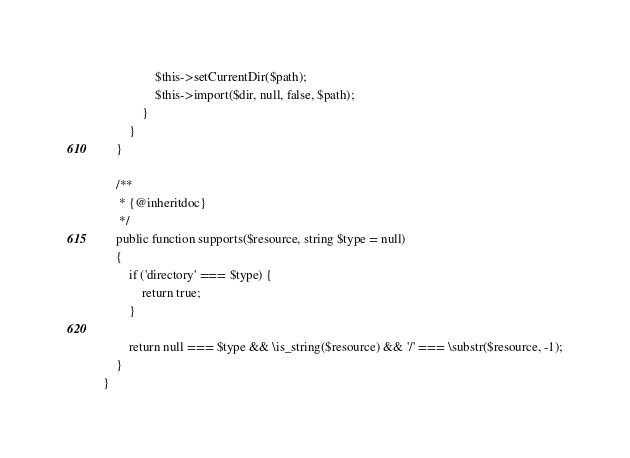Convert code to text. <code><loc_0><loc_0><loc_500><loc_500><_PHP_>
                $this->setCurrentDir($path);
                $this->import($dir, null, false, $path);
            }
        }
    }

    /**
     * {@inheritdoc}
     */
    public function supports($resource, string $type = null)
    {
        if ('directory' === $type) {
            return true;
        }

        return null === $type && \is_string($resource) && '/' === \substr($resource, -1);
    }
}
</code> 